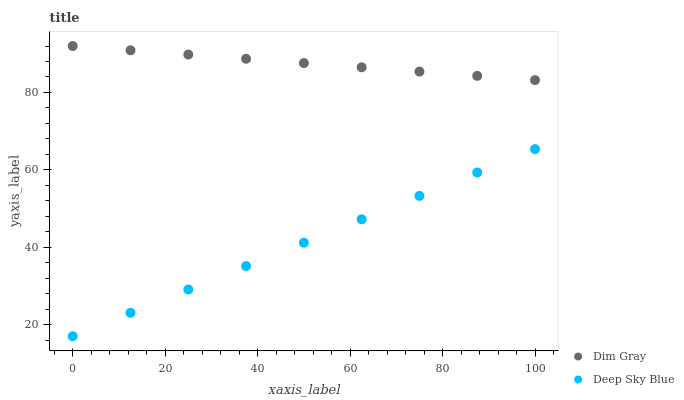Does Deep Sky Blue have the minimum area under the curve?
Answer yes or no. Yes. Does Dim Gray have the maximum area under the curve?
Answer yes or no. Yes. Does Deep Sky Blue have the maximum area under the curve?
Answer yes or no. No. Is Deep Sky Blue the smoothest?
Answer yes or no. Yes. Is Dim Gray the roughest?
Answer yes or no. Yes. Is Deep Sky Blue the roughest?
Answer yes or no. No. Does Deep Sky Blue have the lowest value?
Answer yes or no. Yes. Does Dim Gray have the highest value?
Answer yes or no. Yes. Does Deep Sky Blue have the highest value?
Answer yes or no. No. Is Deep Sky Blue less than Dim Gray?
Answer yes or no. Yes. Is Dim Gray greater than Deep Sky Blue?
Answer yes or no. Yes. Does Deep Sky Blue intersect Dim Gray?
Answer yes or no. No. 